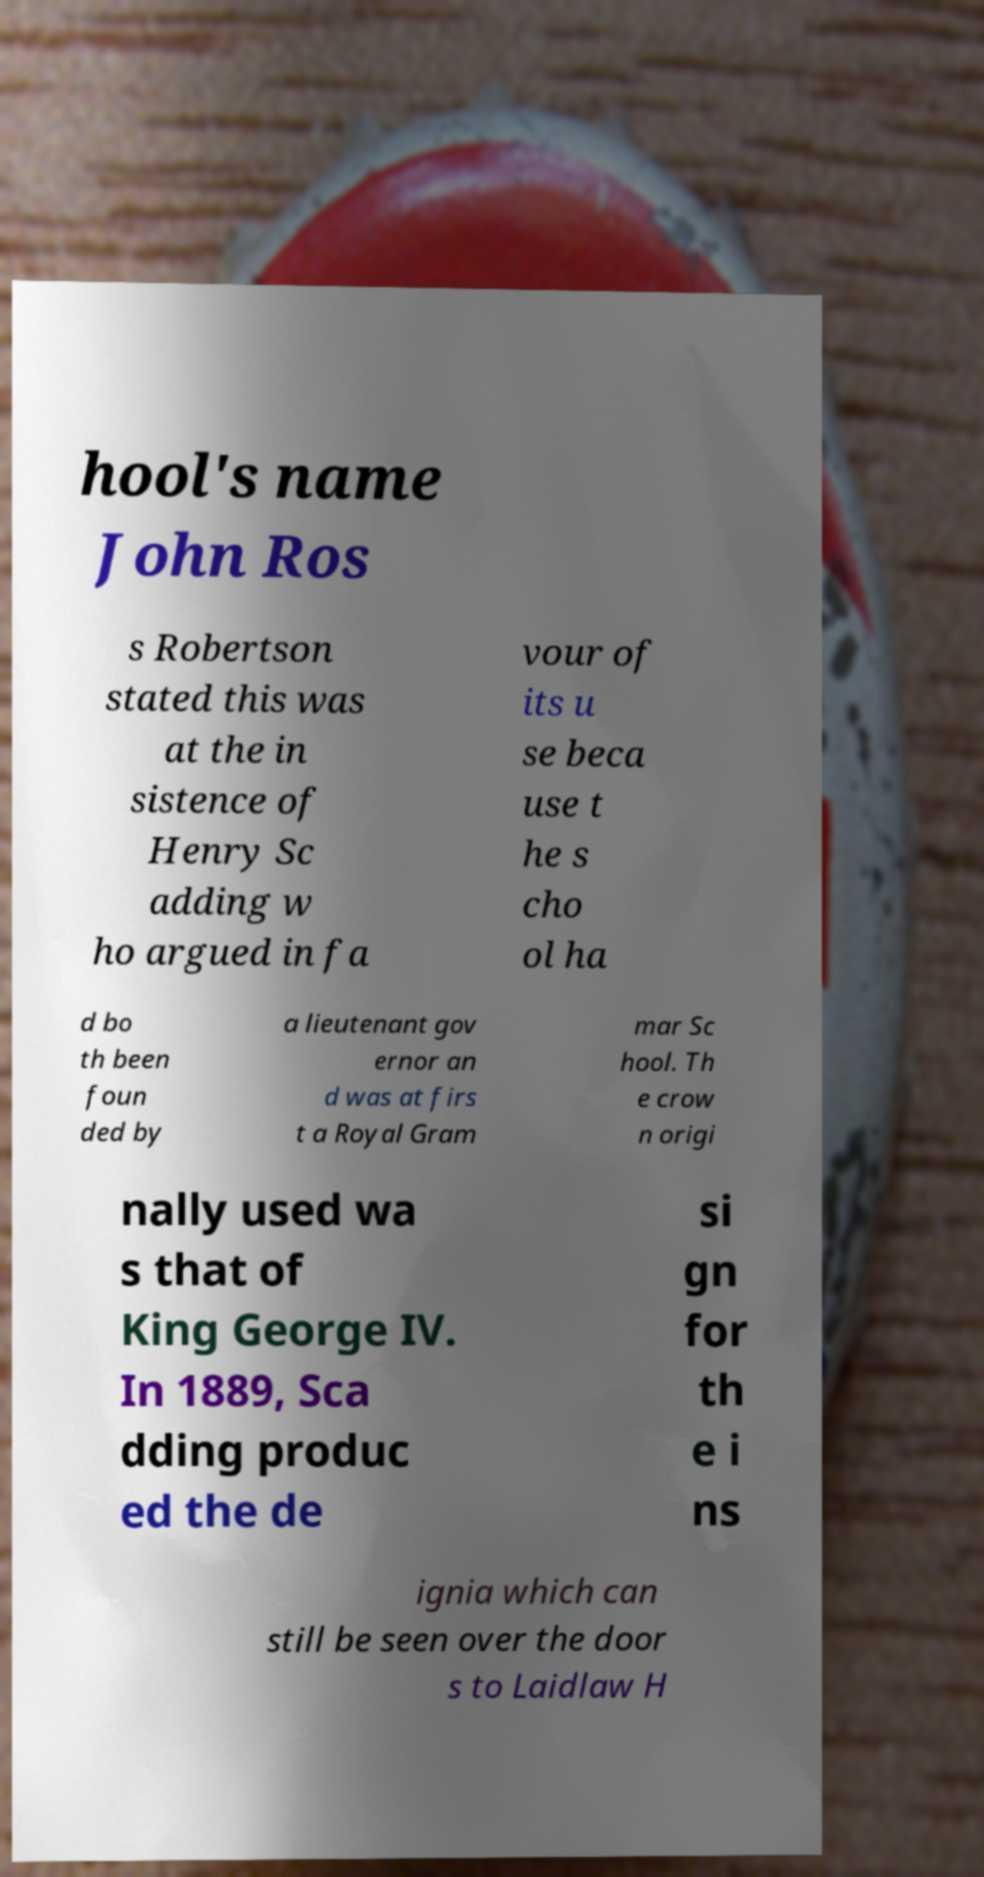For documentation purposes, I need the text within this image transcribed. Could you provide that? hool's name John Ros s Robertson stated this was at the in sistence of Henry Sc adding w ho argued in fa vour of its u se beca use t he s cho ol ha d bo th been foun ded by a lieutenant gov ernor an d was at firs t a Royal Gram mar Sc hool. Th e crow n origi nally used wa s that of King George IV. In 1889, Sca dding produc ed the de si gn for th e i ns ignia which can still be seen over the door s to Laidlaw H 